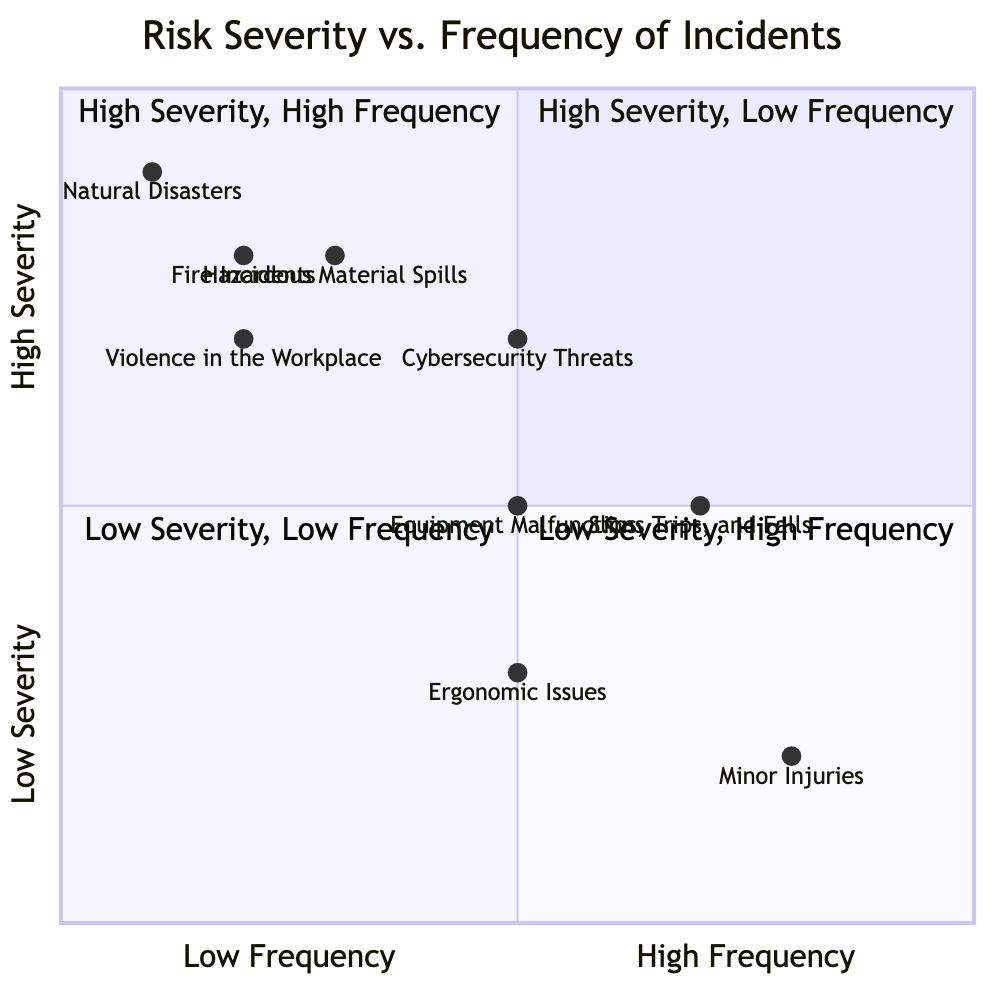What's the location of Cybersecurity Threats in the diagram? Cybersecurity Threats has a frequency of medium (0.5) and severity of high (0.7), which places it in quadrant 1.
Answer: Quadrant 1 Which incident has the highest severity? Natural Disasters have a severity classified as very high (0.9), the highest among all incidents.
Answer: Very High How many incidents are placed in quadrant 4? Quadrant 4 contains Minor Injuries and Slips, Trips, and Falls, totaling two incidents.
Answer: 2 What is the severity level of Hazardous Material Spills? Hazardous Material Spills are categorized as high severity (0.8) according to the diagram.
Answer: High Which incident represents a very low frequency and high severity? Natural Disasters represent a very low frequency (0.1) while having the highest severity (0.9).
Answer: Natural Disasters How does the frequency of Equipment Malfunctions compare to Hazardous Material Spills? Equipment Malfunctions have a medium frequency (0.5), while Hazardous Material Spills have a low frequency (0.3). This indicates that Equipment Malfunctions occur more often than Hazardous Material Spills.
Answer: Equipment Malfunctions occur more often Name the incident with low severity and high frequency. Minor Injuries are characterized by low severity (0.2) and high frequency (0.8) in the chart.
Answer: Minor Injuries Which quadrant contains Violent incidents in the workplace? Violence in the Workplace has high severity (0.7) and low frequency (0.2), placing it in quadrant 1.
Answer: Quadrant 1 Which incidents fall into quadrant 3? Quadrant 3 includes Ergonomic Issues and Minor Injuries, showing low severity and low frequency.
Answer: Ergonomic Issues, Minor Injuries 